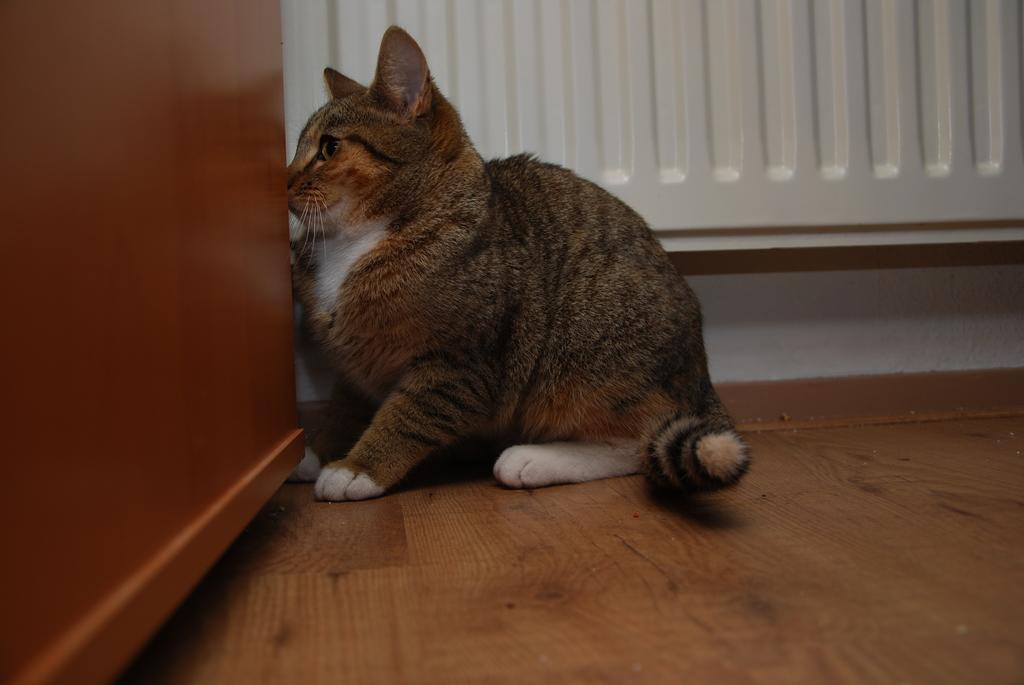What type of animal is in the image? There is a cat in the image. Can you describe the color pattern of the cat? The cat has a brown and white color combination. Where is the cat located in the image? The cat is sitting on the wooden floor. What is the cat near in the image? The cat is near a wooden cupboard. What can be seen in the background of the image? There is a white wall in the background of the image. What advice does the cat give to the viewer in the image? The image does not depict the cat giving any advice to the viewer. 